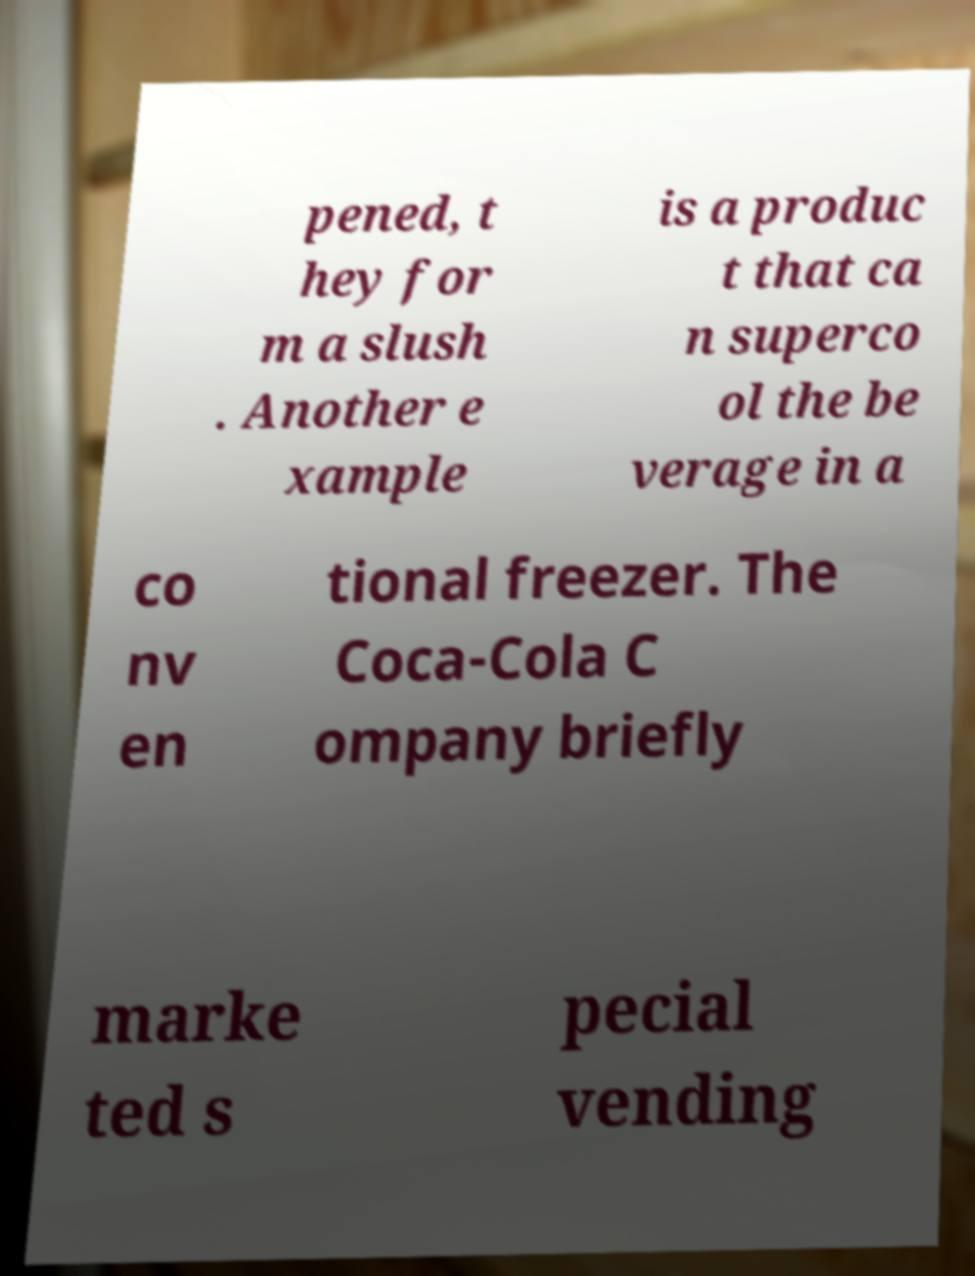Please read and relay the text visible in this image. What does it say? pened, t hey for m a slush . Another e xample is a produc t that ca n superco ol the be verage in a co nv en tional freezer. The Coca-Cola C ompany briefly marke ted s pecial vending 